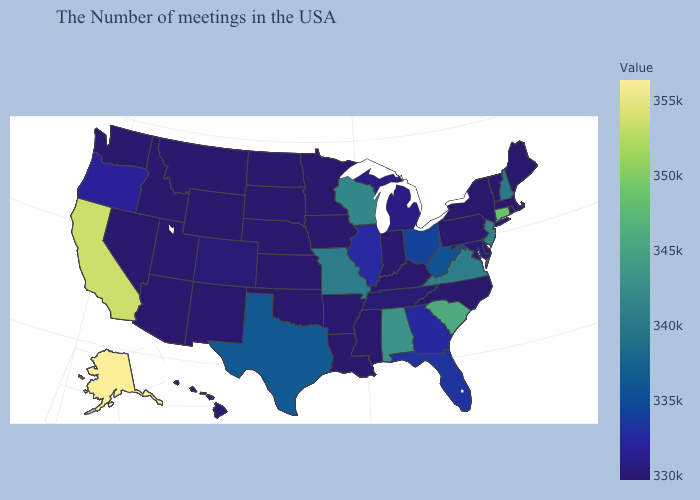Does Virginia have a higher value than South Carolina?
Answer briefly. No. Does New Hampshire have the lowest value in the Northeast?
Concise answer only. No. Does Kansas have the highest value in the MidWest?
Short answer required. No. Is the legend a continuous bar?
Be succinct. Yes. 